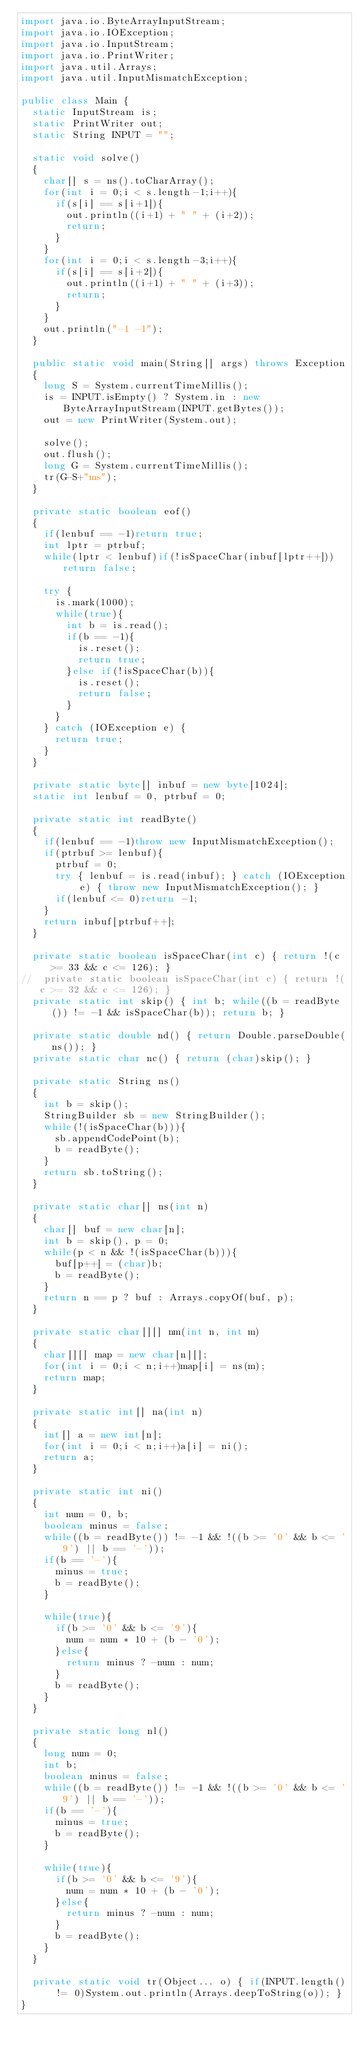Convert code to text. <code><loc_0><loc_0><loc_500><loc_500><_Java_>import java.io.ByteArrayInputStream;
import java.io.IOException;
import java.io.InputStream;
import java.io.PrintWriter;
import java.util.Arrays;
import java.util.InputMismatchException;

public class Main {
	static InputStream is;
	static PrintWriter out;
	static String INPUT = "";
	
	static void solve()
	{
		char[] s = ns().toCharArray();
		for(int i = 0;i < s.length-1;i++){
			if(s[i] == s[i+1]){
				out.println((i+1) + " " + (i+2));
				return;
			}
		}
		for(int i = 0;i < s.length-3;i++){
			if(s[i] == s[i+2]){
				out.println((i+1) + " " + (i+3));
				return;
			}
		}
		out.println("-1 -1");
	}
	
	public static void main(String[] args) throws Exception
	{
		long S = System.currentTimeMillis();
		is = INPUT.isEmpty() ? System.in : new ByteArrayInputStream(INPUT.getBytes());
		out = new PrintWriter(System.out);
		
		solve();
		out.flush();
		long G = System.currentTimeMillis();
		tr(G-S+"ms");
	}
	
	private static boolean eof()
	{
		if(lenbuf == -1)return true;
		int lptr = ptrbuf;
		while(lptr < lenbuf)if(!isSpaceChar(inbuf[lptr++]))return false;
		
		try {
			is.mark(1000);
			while(true){
				int b = is.read();
				if(b == -1){
					is.reset();
					return true;
				}else if(!isSpaceChar(b)){
					is.reset();
					return false;
				}
			}
		} catch (IOException e) {
			return true;
		}
	}
	
	private static byte[] inbuf = new byte[1024];
	static int lenbuf = 0, ptrbuf = 0;
	
	private static int readByte()
	{
		if(lenbuf == -1)throw new InputMismatchException();
		if(ptrbuf >= lenbuf){
			ptrbuf = 0;
			try { lenbuf = is.read(inbuf); } catch (IOException e) { throw new InputMismatchException(); }
			if(lenbuf <= 0)return -1;
		}
		return inbuf[ptrbuf++];
	}
	
	private static boolean isSpaceChar(int c) { return !(c >= 33 && c <= 126); }
//	private static boolean isSpaceChar(int c) { return !(c >= 32 && c <= 126); }
	private static int skip() { int b; while((b = readByte()) != -1 && isSpaceChar(b)); return b; }
	
	private static double nd() { return Double.parseDouble(ns()); }
	private static char nc() { return (char)skip(); }
	
	private static String ns()
	{
		int b = skip();
		StringBuilder sb = new StringBuilder();
		while(!(isSpaceChar(b))){
			sb.appendCodePoint(b);
			b = readByte();
		}
		return sb.toString();
	}
	
	private static char[] ns(int n)
	{
		char[] buf = new char[n];
		int b = skip(), p = 0;
		while(p < n && !(isSpaceChar(b))){
			buf[p++] = (char)b;
			b = readByte();
		}
		return n == p ? buf : Arrays.copyOf(buf, p);
	}
	
	private static char[][] nm(int n, int m)
	{
		char[][] map = new char[n][];
		for(int i = 0;i < n;i++)map[i] = ns(m);
		return map;
	}
	
	private static int[] na(int n)
	{
		int[] a = new int[n];
		for(int i = 0;i < n;i++)a[i] = ni();
		return a;
	}
	
	private static int ni()
	{
		int num = 0, b;
		boolean minus = false;
		while((b = readByte()) != -1 && !((b >= '0' && b <= '9') || b == '-'));
		if(b == '-'){
			minus = true;
			b = readByte();
		}
		
		while(true){
			if(b >= '0' && b <= '9'){
				num = num * 10 + (b - '0');
			}else{
				return minus ? -num : num;
			}
			b = readByte();
		}
	}
	
	private static long nl()
	{
		long num = 0;
		int b;
		boolean minus = false;
		while((b = readByte()) != -1 && !((b >= '0' && b <= '9') || b == '-'));
		if(b == '-'){
			minus = true;
			b = readByte();
		}
		
		while(true){
			if(b >= '0' && b <= '9'){
				num = num * 10 + (b - '0');
			}else{
				return minus ? -num : num;
			}
			b = readByte();
		}
	}
	
	private static void tr(Object... o) { if(INPUT.length() != 0)System.out.println(Arrays.deepToString(o)); }
}
</code> 